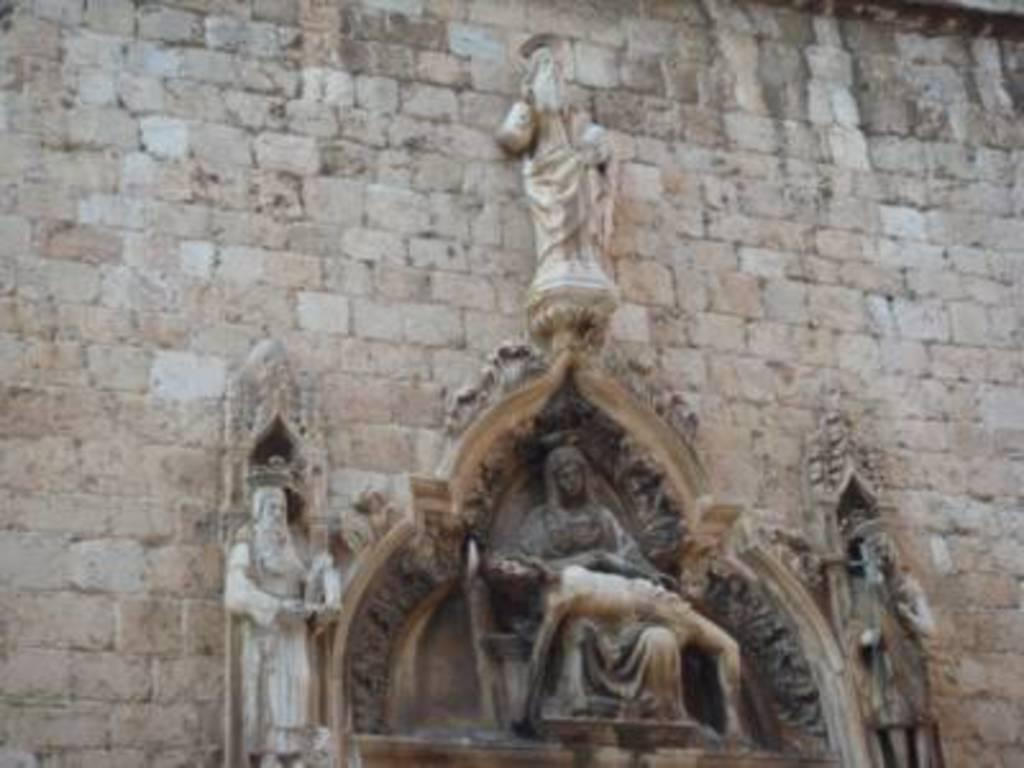What can be seen on the wall in the image? There are sculptures and designs on the wall in the image. Can you describe the describe the sculptures on the wall? Unfortunately, the details of the sculptures cannot be discerned from the image. What type of designs are present on the wall? The specific designs on the wall cannot be identified from the image. How many dogs are wearing hats in the image? There are no dogs or hats present in the image. 